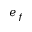Convert formula to latex. <formula><loc_0><loc_0><loc_500><loc_500>e _ { f }</formula> 